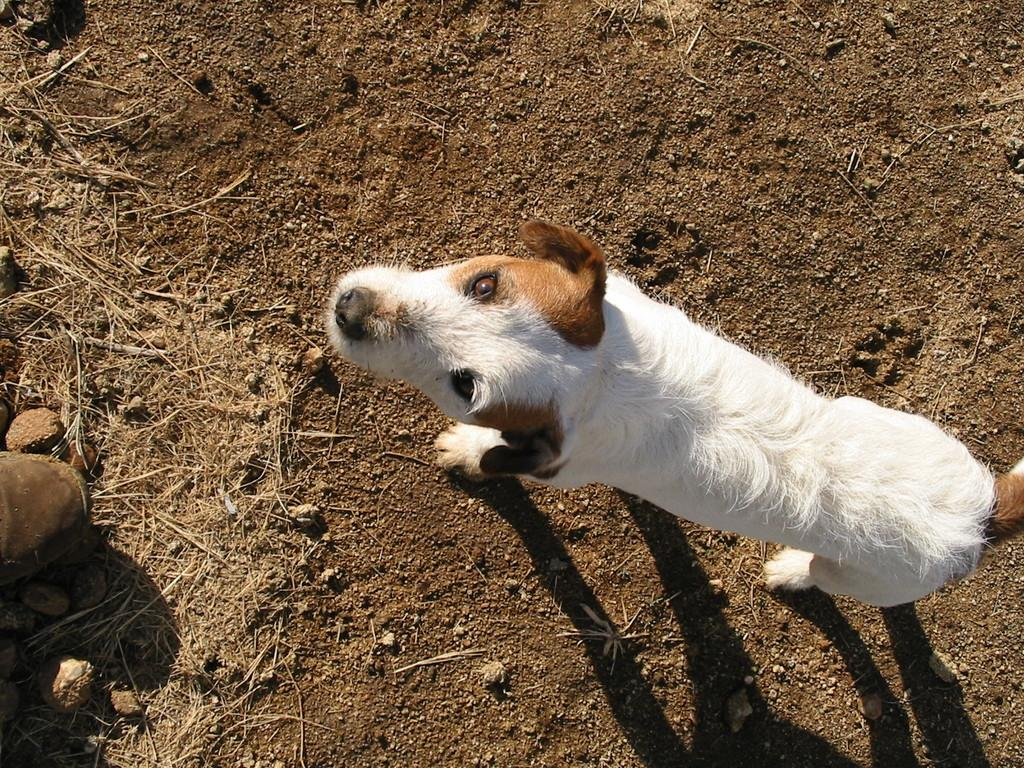What type of animal is in the image? There is a white color dog in the image. What is the dog doing in the image? The dog is standing on the ground. Which direction is the dog facing? The dog is facing towards the left side. What else can be seen on the ground in the image? There is a shoe on the ground on the left side. What kind of terrain is visible in the image? There are stones visible in the image. What flavor of cheese is the dog eating in the image? There is no cheese present in the image, and therefore no flavor can be determined. 